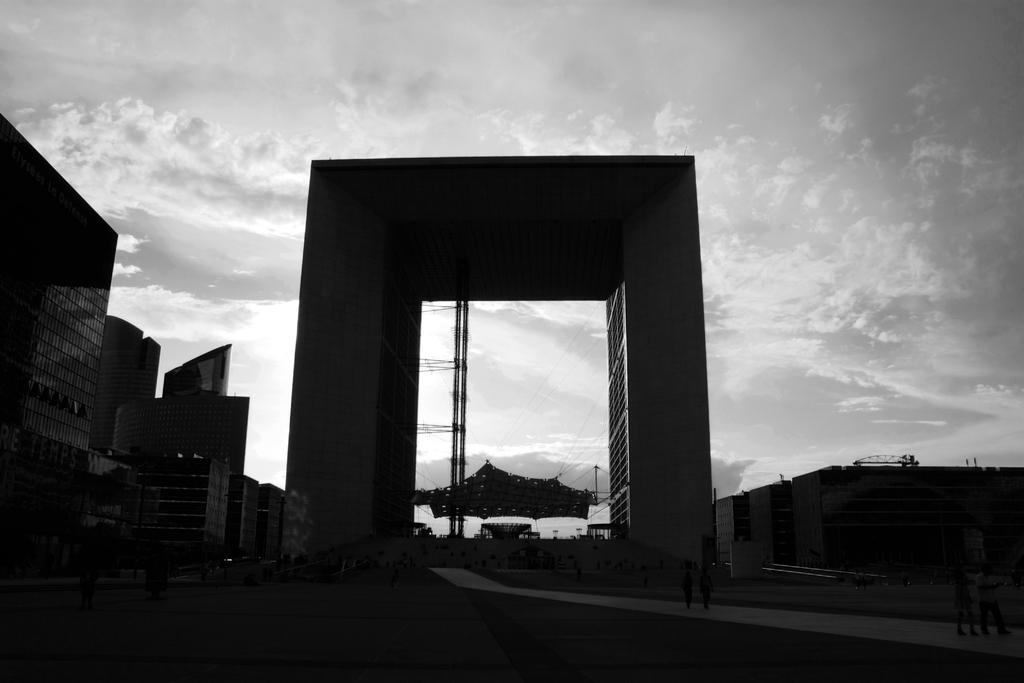What type of structures are present in the image? There are buildings in the image. How are the buildings arranged in the image? The buildings are arranged from left to right. What is the condition of the sky in the image? The sky is cloudy in the image. How many servants can be seen attending to the buildings in the image? There are no servants present in the image; it only features buildings. What level of the building is the vein located on in the image? There are no veins present in the image, as it only features buildings and a cloudy sky. 